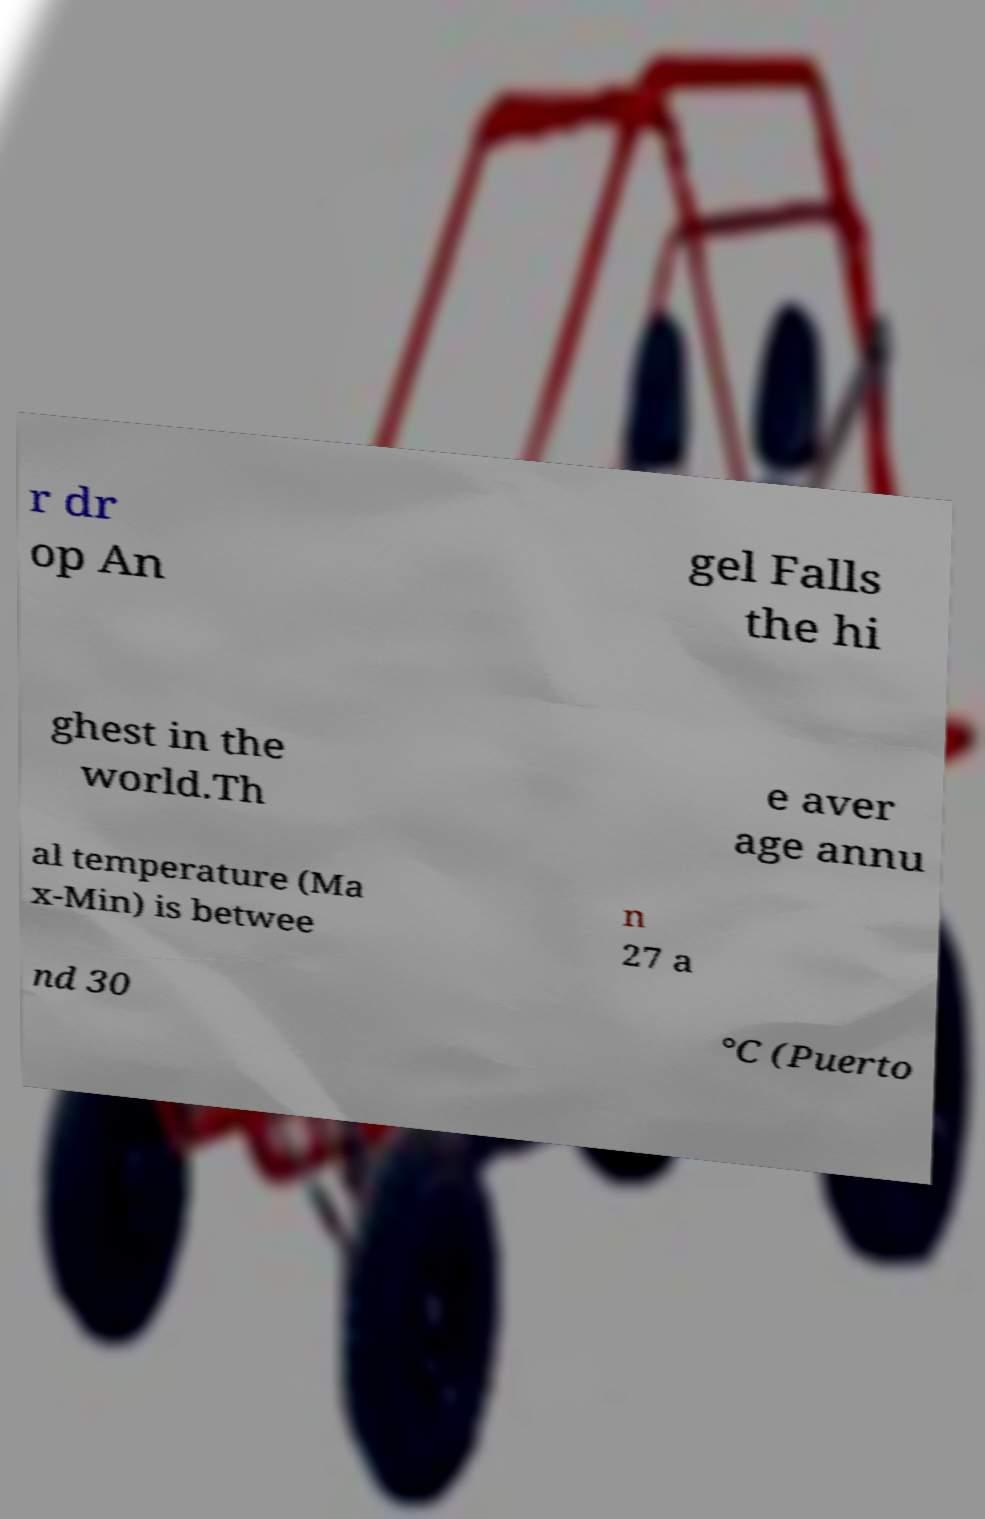Please identify and transcribe the text found in this image. r dr op An gel Falls the hi ghest in the world.Th e aver age annu al temperature (Ma x-Min) is betwee n 27 a nd 30 °C (Puerto 